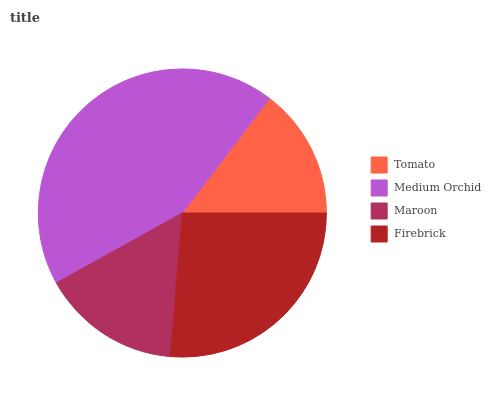Is Tomato the minimum?
Answer yes or no. Yes. Is Medium Orchid the maximum?
Answer yes or no. Yes. Is Maroon the minimum?
Answer yes or no. No. Is Maroon the maximum?
Answer yes or no. No. Is Medium Orchid greater than Maroon?
Answer yes or no. Yes. Is Maroon less than Medium Orchid?
Answer yes or no. Yes. Is Maroon greater than Medium Orchid?
Answer yes or no. No. Is Medium Orchid less than Maroon?
Answer yes or no. No. Is Firebrick the high median?
Answer yes or no. Yes. Is Maroon the low median?
Answer yes or no. Yes. Is Medium Orchid the high median?
Answer yes or no. No. Is Tomato the low median?
Answer yes or no. No. 